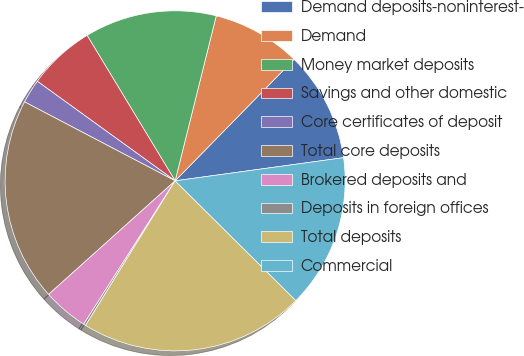<chart> <loc_0><loc_0><loc_500><loc_500><pie_chart><fcel>Demand deposits-noninterest-<fcel>Demand<fcel>Money market deposits<fcel>Savings and other domestic<fcel>Core certificates of deposit<fcel>Total core deposits<fcel>Brokered deposits and<fcel>Deposits in foreign offices<fcel>Total deposits<fcel>Commercial<nl><fcel>10.5%<fcel>8.44%<fcel>12.55%<fcel>6.38%<fcel>2.27%<fcel>19.33%<fcel>4.32%<fcel>0.21%<fcel>21.39%<fcel>14.61%<nl></chart> 